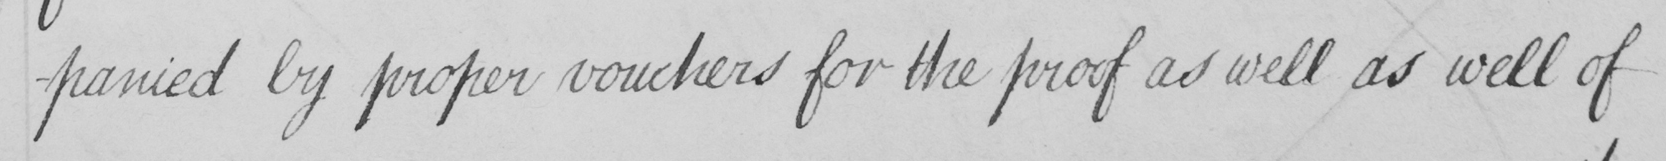What does this handwritten line say? -panied by proper vouchers for the proof as well as well of 